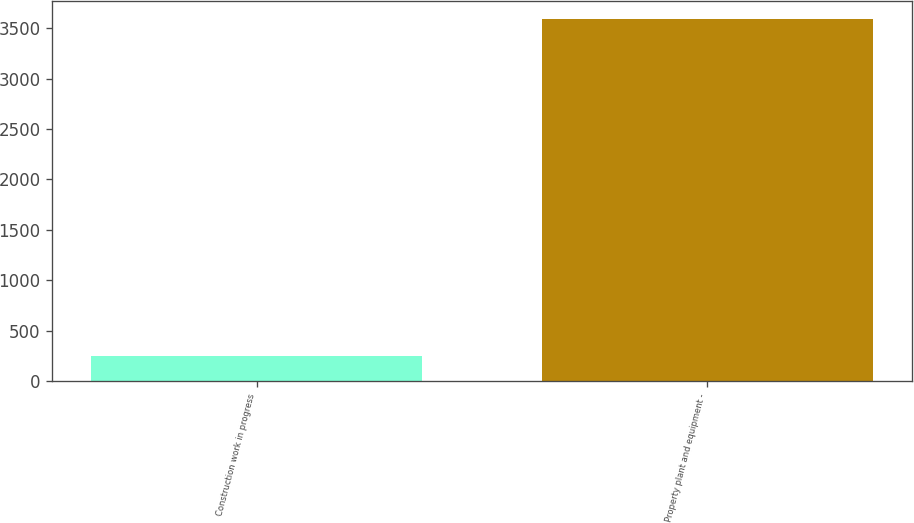Convert chart to OTSL. <chart><loc_0><loc_0><loc_500><loc_500><bar_chart><fcel>Construction work in progress<fcel>Property plant and equipment -<nl><fcel>252<fcel>3592<nl></chart> 